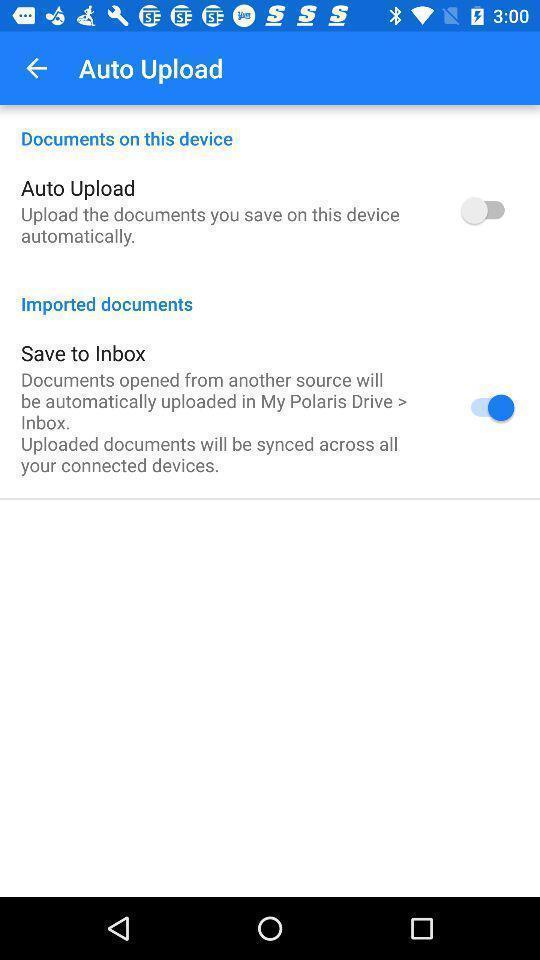What can you discern from this picture? Page showing auto upload options. 